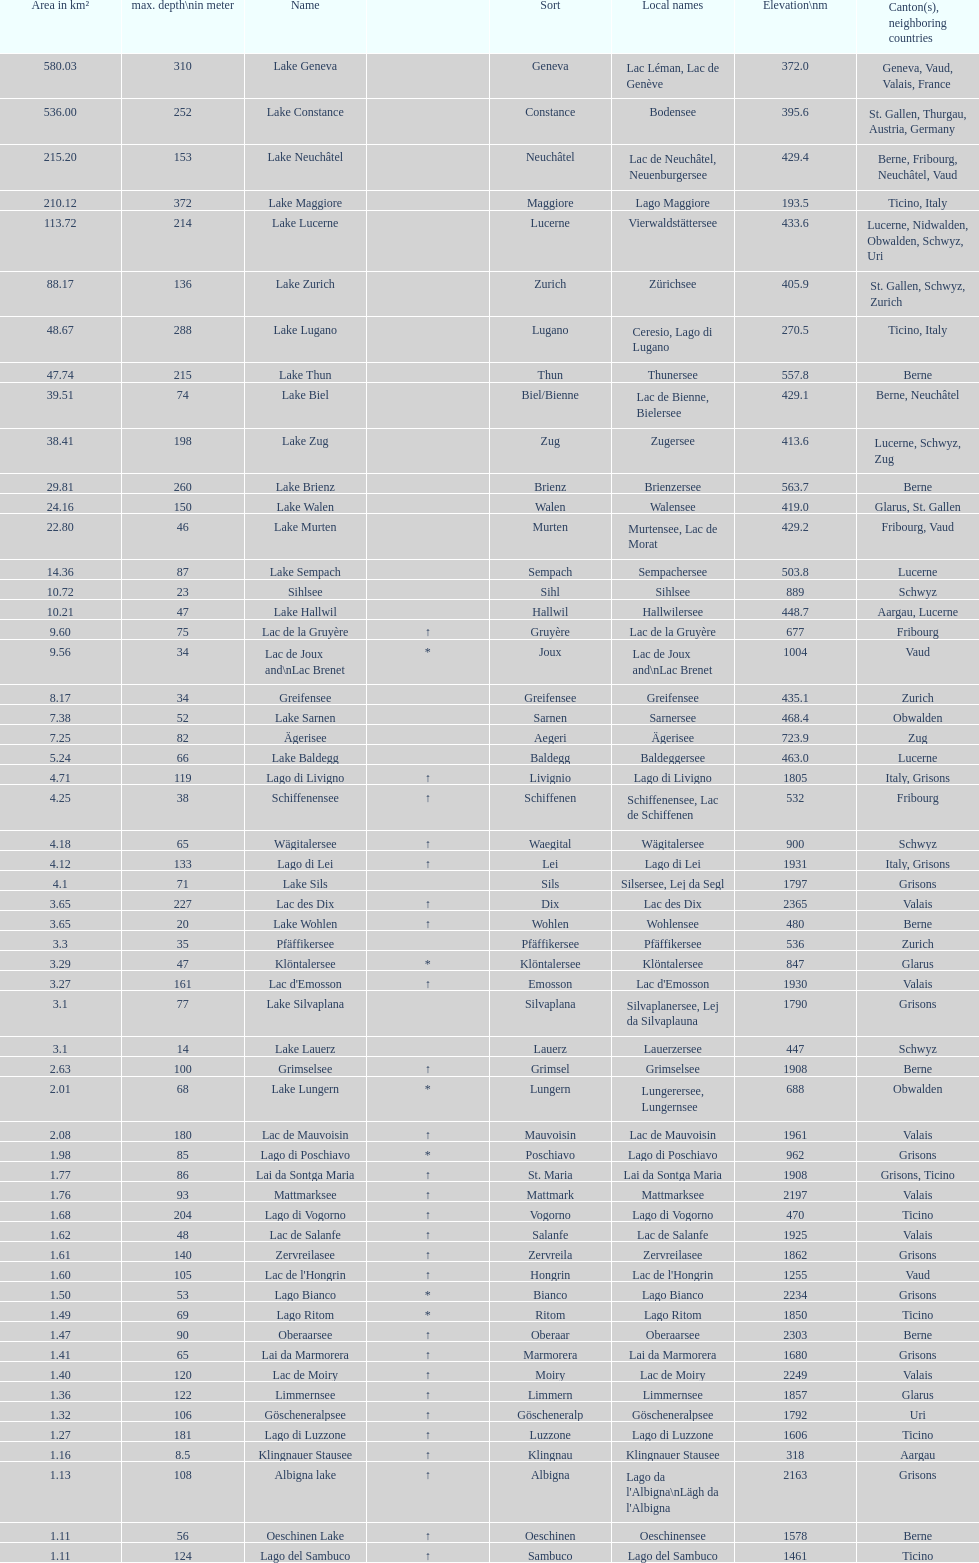Which is the only lake with a max depth of 372m? Lake Maggiore. 